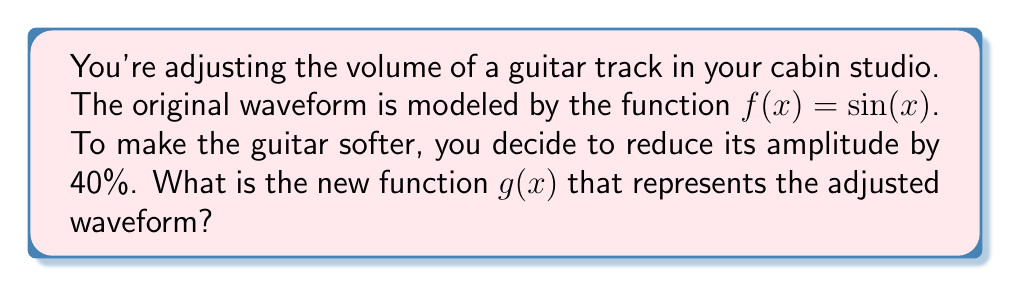What is the answer to this math problem? Let's approach this step-by-step:

1) The original function is $f(x) = \sin(x)$. This has an amplitude of 1.

2) To change the amplitude of a sine function, we multiply it by a constant. The general form is:

   $g(x) = a \cdot \sin(x)$

   where $a$ is the new amplitude.

3) We want to reduce the amplitude by 40%. This means the new amplitude will be 60% of the original.

4) To calculate the new amplitude:
   
   New amplitude = Original amplitude × (100% - Reduction percentage)
                 = 1 × (100% - 40%)
                 = 1 × 60%
                 = 0.6

5) Therefore, our new function will be:

   $g(x) = 0.6 \cdot \sin(x)$

This function represents the softened guitar track with 60% of its original amplitude.
Answer: $g(x) = 0.6\sin(x)$ 